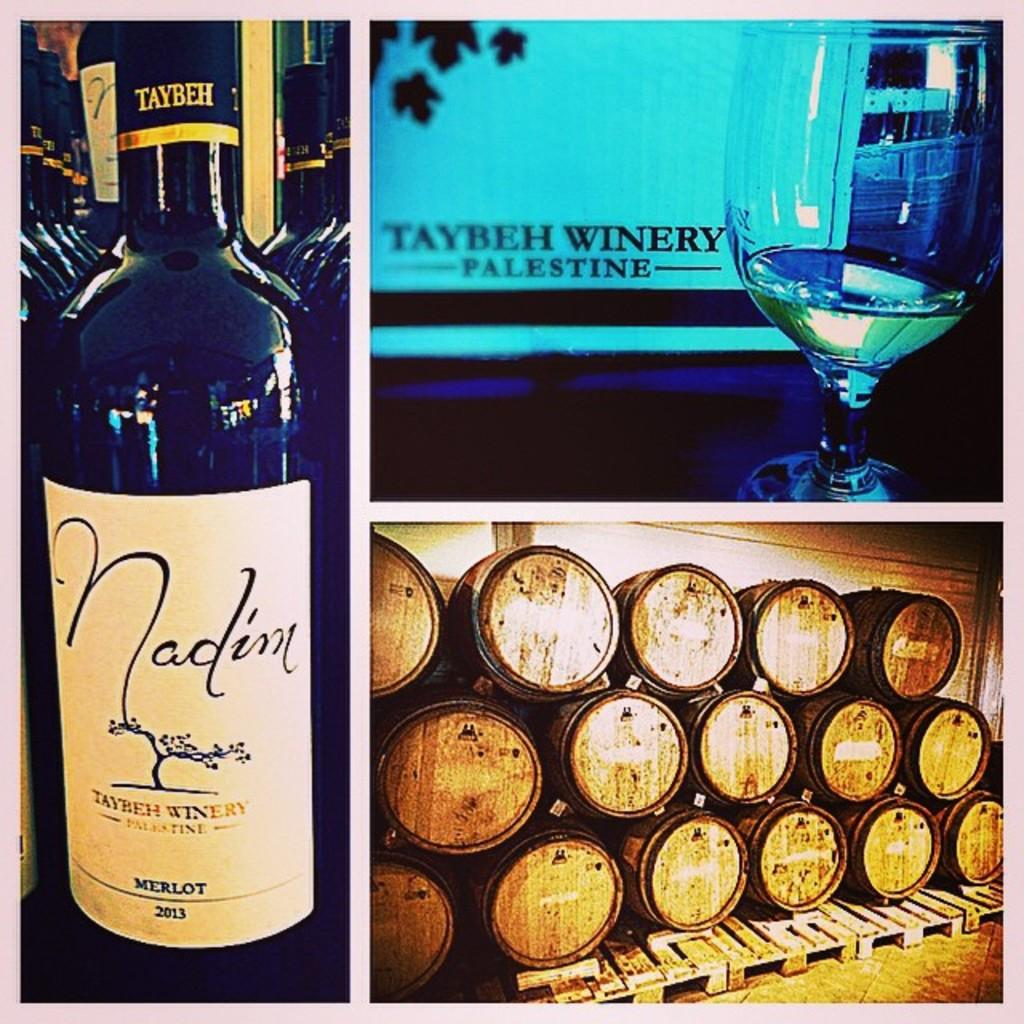<image>
Present a compact description of the photo's key features. A composite image has wine barrels in one picture, a bottle of Nadim wine in another and a wine glass in the third image. 